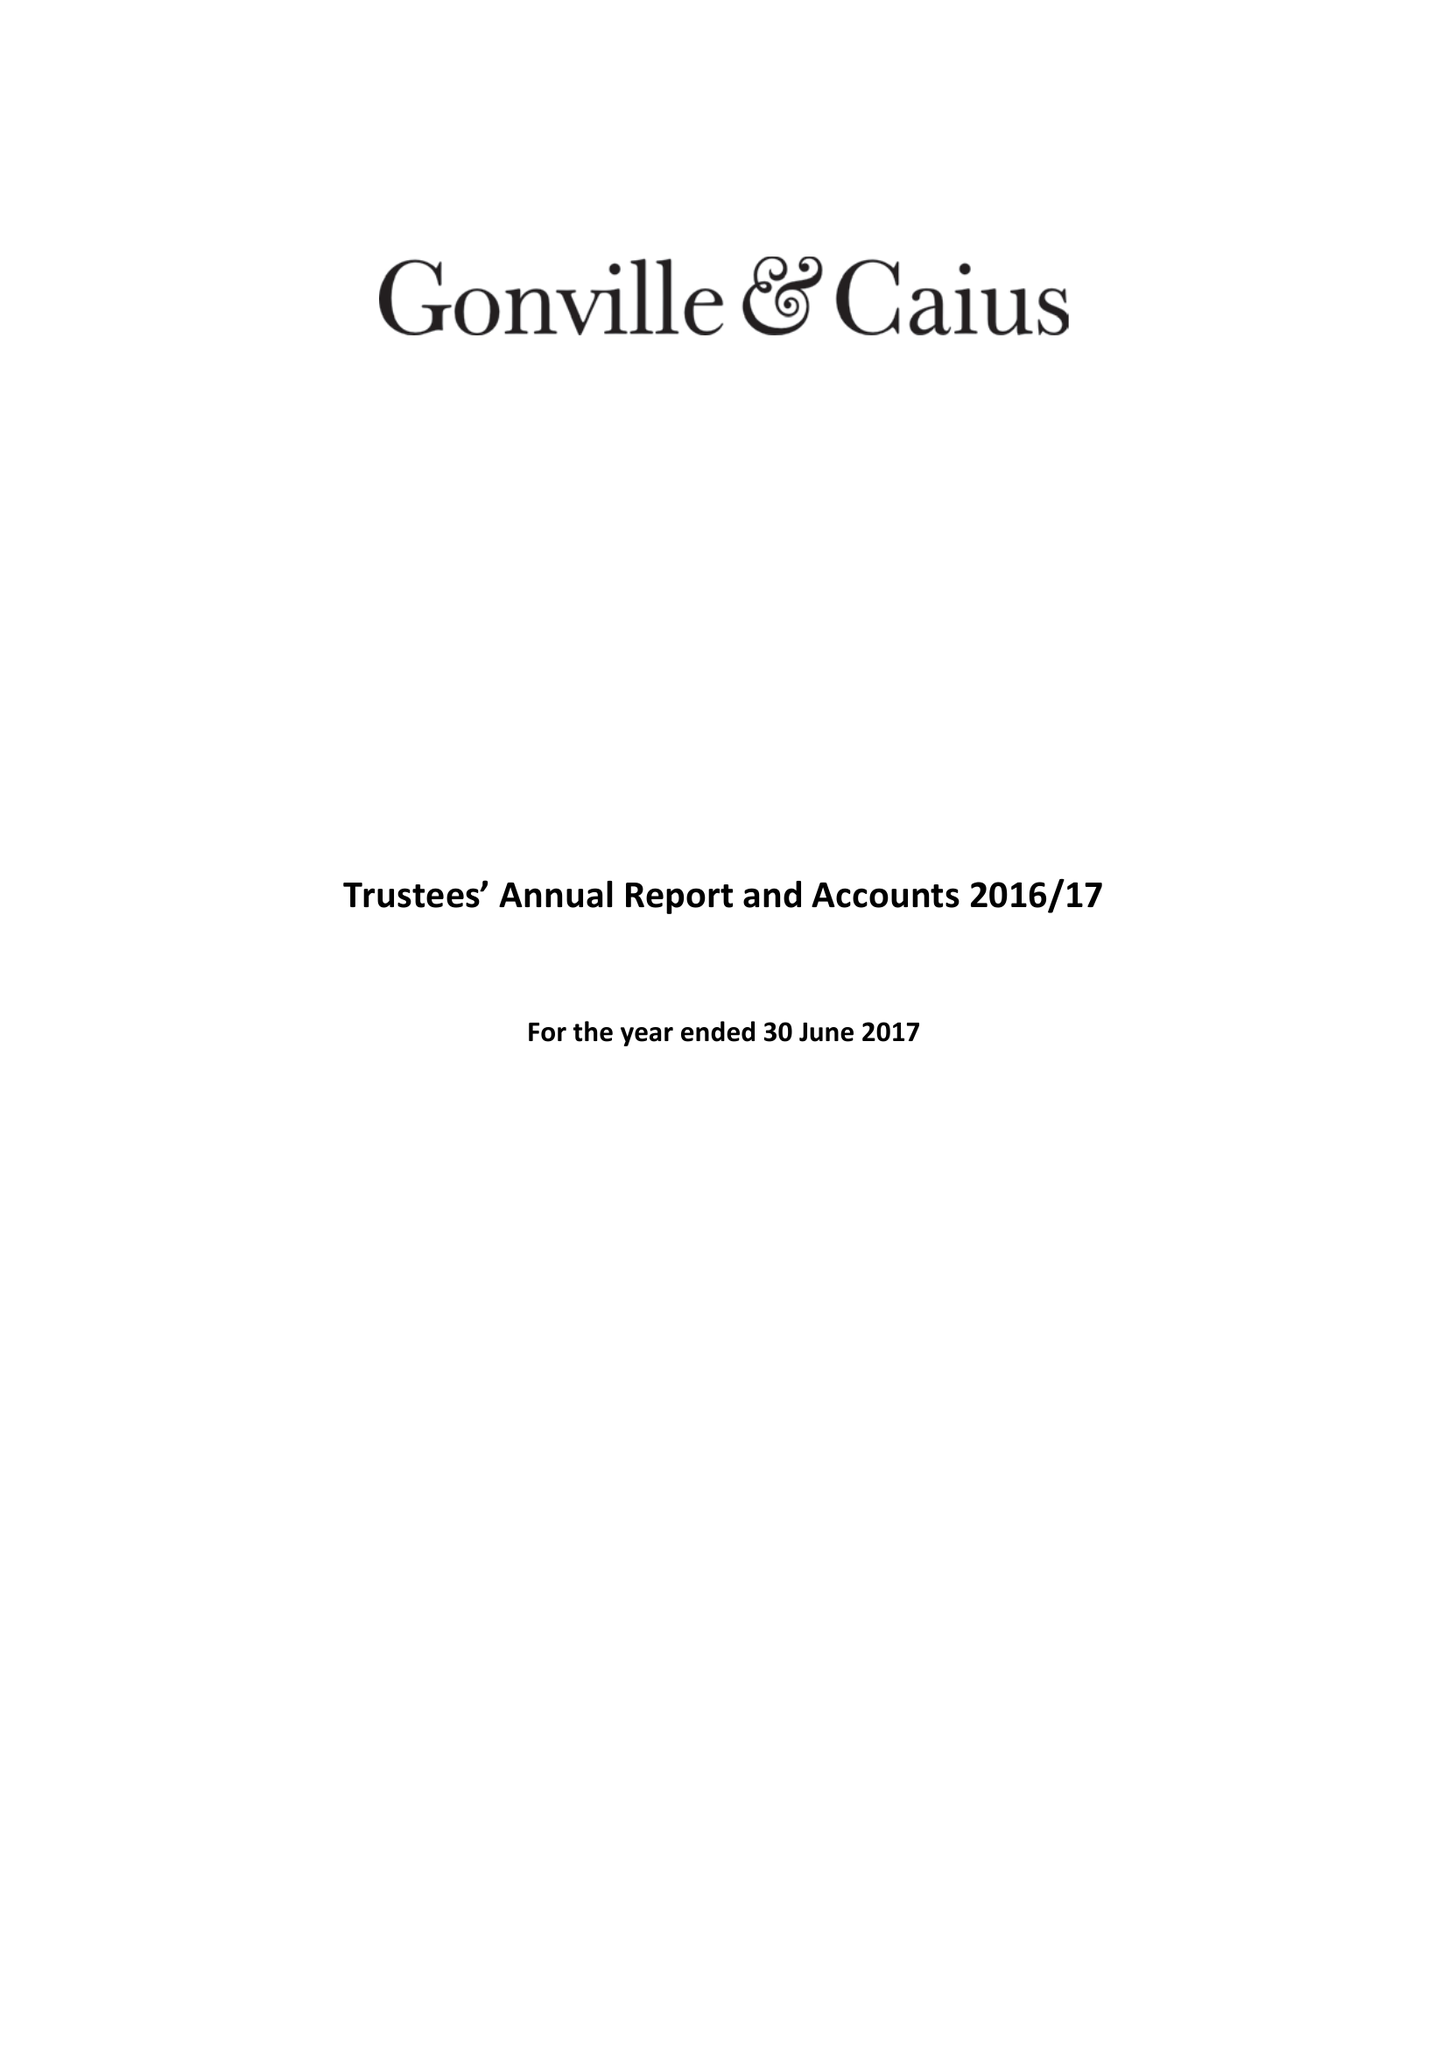What is the value for the charity_name?
Answer the question using a single word or phrase. Gonville and Caius College 